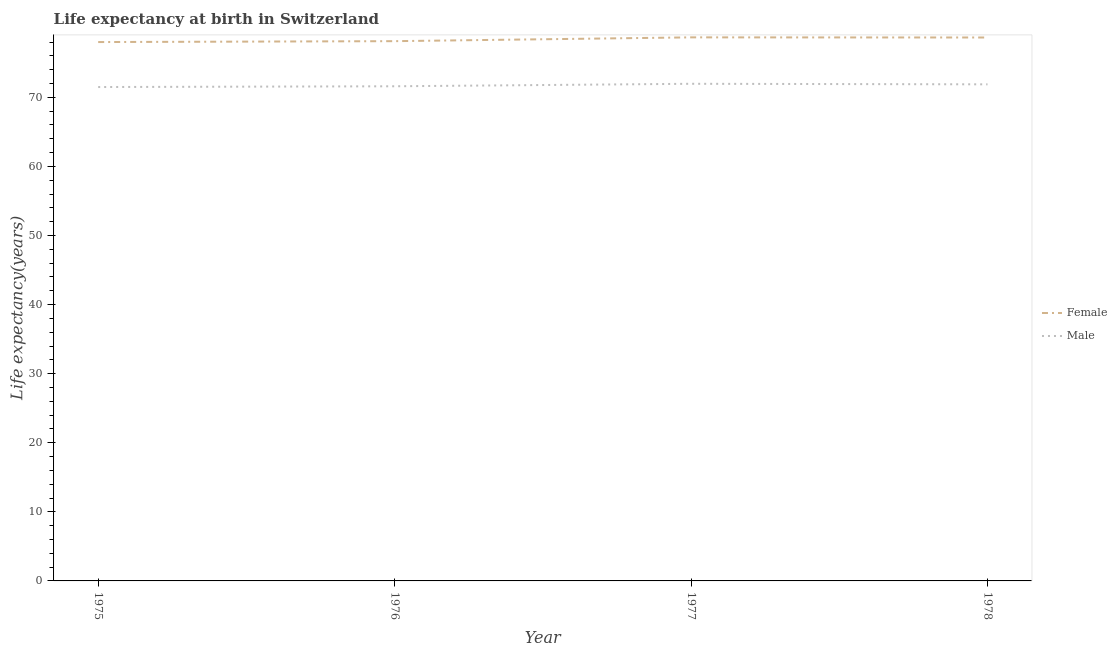How many different coloured lines are there?
Make the answer very short. 2. Does the line corresponding to life expectancy(male) intersect with the line corresponding to life expectancy(female)?
Give a very brief answer. No. Is the number of lines equal to the number of legend labels?
Your response must be concise. Yes. Across all years, what is the maximum life expectancy(male)?
Offer a terse response. 71.96. In which year was the life expectancy(female) maximum?
Your answer should be very brief. 1977. In which year was the life expectancy(male) minimum?
Offer a very short reply. 1975. What is the total life expectancy(female) in the graph?
Make the answer very short. 313.47. What is the difference between the life expectancy(male) in 1977 and that in 1978?
Provide a short and direct response. 0.08. What is the difference between the life expectancy(female) in 1977 and the life expectancy(male) in 1978?
Offer a terse response. 6.8. What is the average life expectancy(male) per year?
Provide a succinct answer. 71.73. In the year 1976, what is the difference between the life expectancy(female) and life expectancy(male)?
Make the answer very short. 6.53. In how many years, is the life expectancy(female) greater than 34 years?
Provide a short and direct response. 4. What is the ratio of the life expectancy(male) in 1977 to that in 1978?
Your answer should be compact. 1. What is the difference between the highest and the second highest life expectancy(male)?
Your response must be concise. 0.08. What is the difference between the highest and the lowest life expectancy(female)?
Provide a succinct answer. 0.68. Does the life expectancy(female) monotonically increase over the years?
Make the answer very short. No. How many years are there in the graph?
Offer a very short reply. 4. What is the difference between two consecutive major ticks on the Y-axis?
Make the answer very short. 10. Does the graph contain any zero values?
Provide a succinct answer. No. Where does the legend appear in the graph?
Offer a terse response. Center right. How many legend labels are there?
Offer a terse response. 2. How are the legend labels stacked?
Your answer should be compact. Vertical. What is the title of the graph?
Offer a very short reply. Life expectancy at birth in Switzerland. Does "US$" appear as one of the legend labels in the graph?
Give a very brief answer. No. What is the label or title of the X-axis?
Your response must be concise. Year. What is the label or title of the Y-axis?
Your response must be concise. Life expectancy(years). What is the Life expectancy(years) in Female in 1975?
Your answer should be compact. 78. What is the Life expectancy(years) of Male in 1975?
Keep it short and to the point. 71.49. What is the Life expectancy(years) in Female in 1976?
Your response must be concise. 78.13. What is the Life expectancy(years) in Male in 1976?
Give a very brief answer. 71.6. What is the Life expectancy(years) of Female in 1977?
Your answer should be compact. 78.68. What is the Life expectancy(years) of Male in 1977?
Your answer should be very brief. 71.96. What is the Life expectancy(years) of Female in 1978?
Offer a very short reply. 78.66. What is the Life expectancy(years) of Male in 1978?
Provide a succinct answer. 71.88. Across all years, what is the maximum Life expectancy(years) of Female?
Provide a short and direct response. 78.68. Across all years, what is the maximum Life expectancy(years) of Male?
Offer a very short reply. 71.96. Across all years, what is the minimum Life expectancy(years) of Male?
Give a very brief answer. 71.49. What is the total Life expectancy(years) of Female in the graph?
Ensure brevity in your answer.  313.47. What is the total Life expectancy(years) of Male in the graph?
Your answer should be very brief. 286.93. What is the difference between the Life expectancy(years) in Female in 1975 and that in 1976?
Make the answer very short. -0.13. What is the difference between the Life expectancy(years) of Male in 1975 and that in 1976?
Provide a succinct answer. -0.11. What is the difference between the Life expectancy(years) of Female in 1975 and that in 1977?
Make the answer very short. -0.68. What is the difference between the Life expectancy(years) of Male in 1975 and that in 1977?
Make the answer very short. -0.47. What is the difference between the Life expectancy(years) of Female in 1975 and that in 1978?
Ensure brevity in your answer.  -0.66. What is the difference between the Life expectancy(years) in Male in 1975 and that in 1978?
Ensure brevity in your answer.  -0.39. What is the difference between the Life expectancy(years) in Female in 1976 and that in 1977?
Give a very brief answer. -0.55. What is the difference between the Life expectancy(years) of Male in 1976 and that in 1977?
Your response must be concise. -0.36. What is the difference between the Life expectancy(years) in Female in 1976 and that in 1978?
Offer a terse response. -0.53. What is the difference between the Life expectancy(years) in Male in 1976 and that in 1978?
Your answer should be compact. -0.28. What is the difference between the Life expectancy(years) of Female in 1977 and that in 1978?
Offer a very short reply. 0.02. What is the difference between the Life expectancy(years) of Male in 1977 and that in 1978?
Provide a succinct answer. 0.08. What is the difference between the Life expectancy(years) in Female in 1975 and the Life expectancy(years) in Male in 1977?
Your response must be concise. 6.04. What is the difference between the Life expectancy(years) of Female in 1975 and the Life expectancy(years) of Male in 1978?
Offer a very short reply. 6.12. What is the difference between the Life expectancy(years) of Female in 1976 and the Life expectancy(years) of Male in 1977?
Offer a very short reply. 6.17. What is the difference between the Life expectancy(years) in Female in 1976 and the Life expectancy(years) in Male in 1978?
Your response must be concise. 6.25. What is the average Life expectancy(years) of Female per year?
Provide a short and direct response. 78.37. What is the average Life expectancy(years) of Male per year?
Your answer should be compact. 71.73. In the year 1975, what is the difference between the Life expectancy(years) in Female and Life expectancy(years) in Male?
Ensure brevity in your answer.  6.51. In the year 1976, what is the difference between the Life expectancy(years) of Female and Life expectancy(years) of Male?
Provide a short and direct response. 6.53. In the year 1977, what is the difference between the Life expectancy(years) in Female and Life expectancy(years) in Male?
Offer a very short reply. 6.72. In the year 1978, what is the difference between the Life expectancy(years) in Female and Life expectancy(years) in Male?
Provide a short and direct response. 6.78. What is the ratio of the Life expectancy(years) in Male in 1975 to that in 1977?
Provide a succinct answer. 0.99. What is the ratio of the Life expectancy(years) in Female in 1975 to that in 1978?
Offer a terse response. 0.99. What is the ratio of the Life expectancy(years) of Male in 1975 to that in 1978?
Give a very brief answer. 0.99. What is the ratio of the Life expectancy(years) of Female in 1976 to that in 1977?
Your answer should be very brief. 0.99. What is the ratio of the Life expectancy(years) in Female in 1976 to that in 1978?
Make the answer very short. 0.99. What is the difference between the highest and the lowest Life expectancy(years) in Female?
Offer a terse response. 0.68. What is the difference between the highest and the lowest Life expectancy(years) of Male?
Your response must be concise. 0.47. 